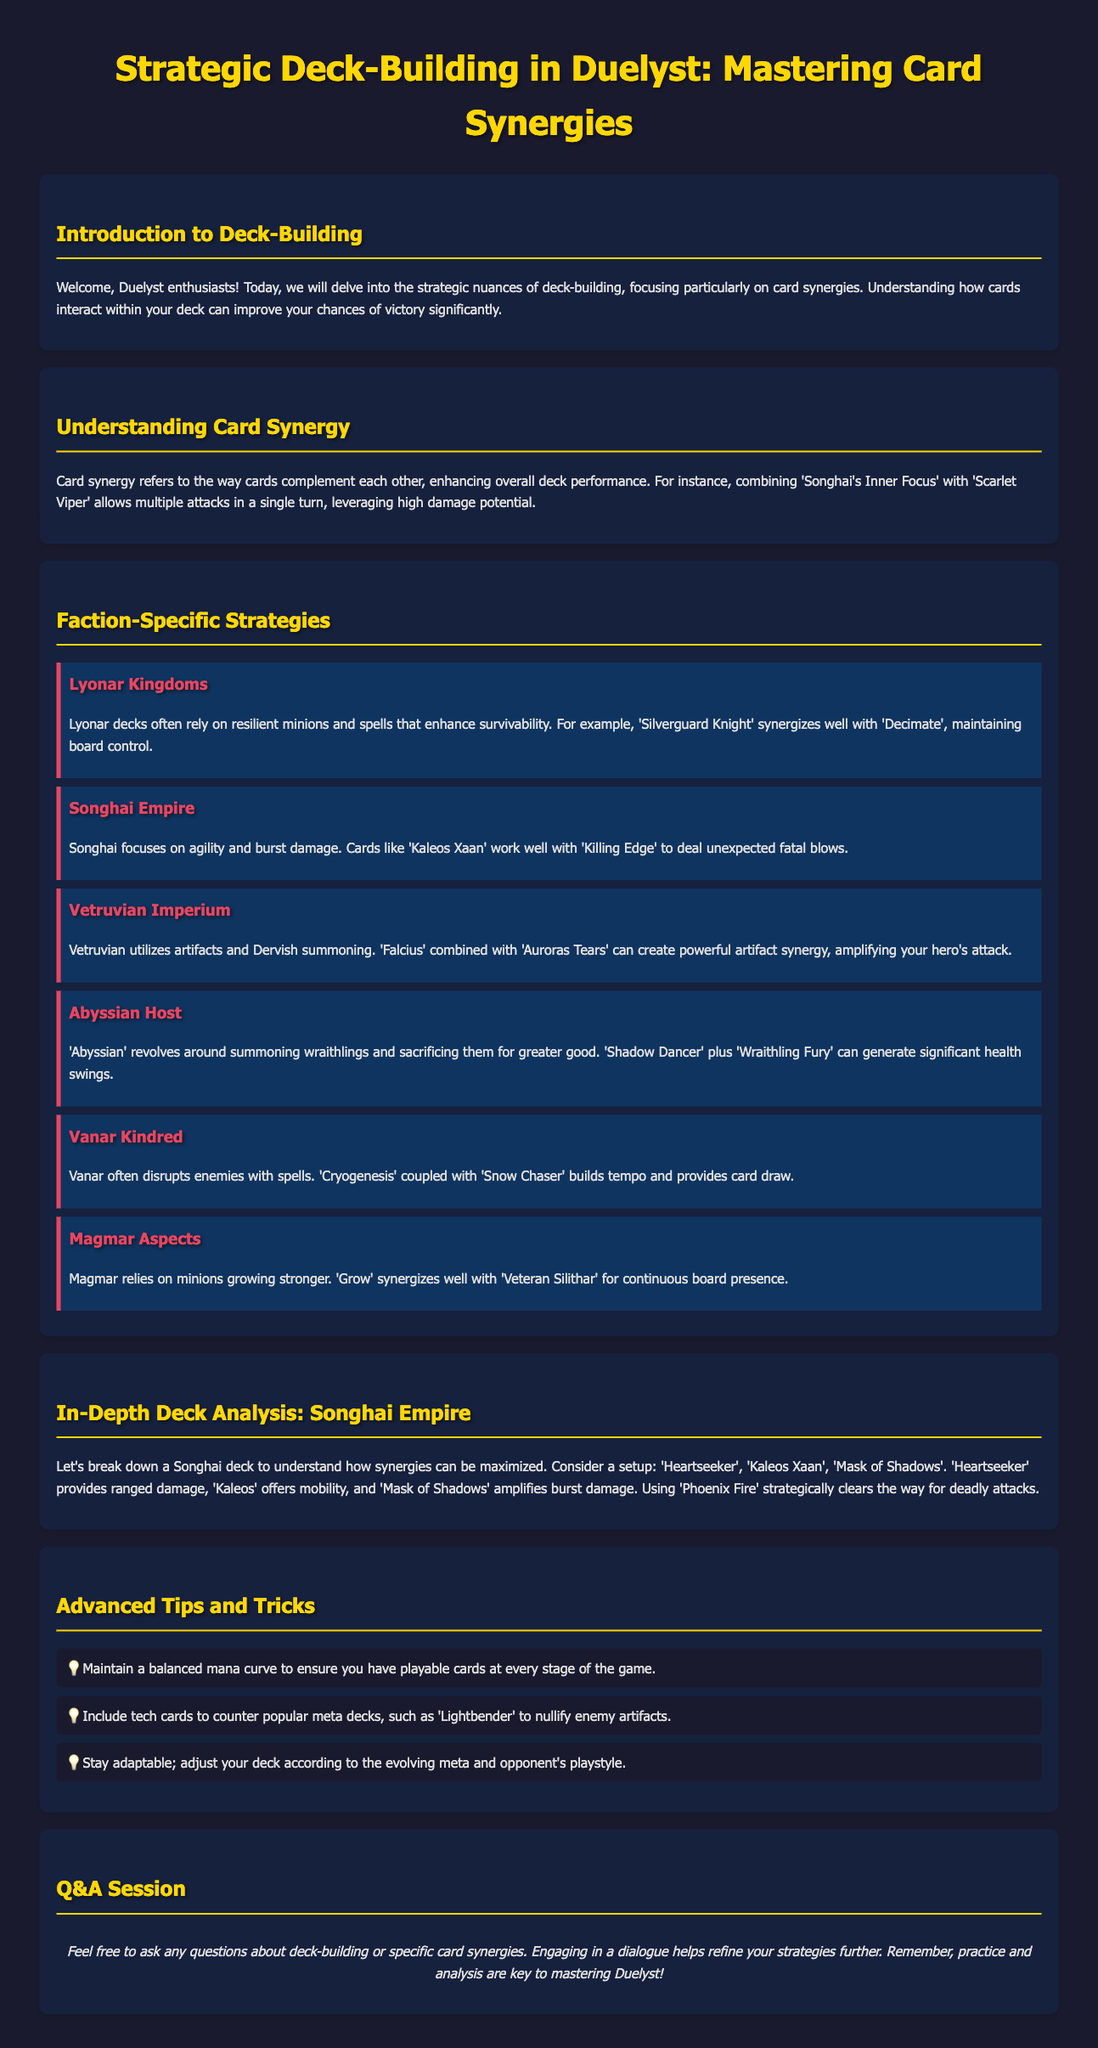What is the title of the workshop? The title of the workshop is presented at the top of the document.
Answer: Strategic Deck-Building in Duelyst: Mastering Card Synergies Which faction is associated with resilient minions? The workshop describes that Lyonar Kingdoms often rely on resilient minions.
Answer: Lyonar Kingdoms What card synergizes well with 'Kaleos Xaan'? The document indicates that 'Killing Edge' works well with 'Kaleos Xaan'.
Answer: Killing Edge How does 'Cryogenesis' benefit Vanar Kindred? The text explains that 'Cryogenesis' coupled with 'Snow Chaser' builds tempo and provides card draw.
Answer: Builds tempo and provides card draw What concept is described as how cards complement each other? The definition in the document describes this concept explicitly.
Answer: Card synergy Which card is mentioned as part of the in-depth analysis for Songhai Empire? The analysis includes specific cards utilized in the Songhai deck example.
Answer: Heartseeker What advanced tip is given regarding mana curve? The document suggests maintaining a balanced mana curve for gameplay strategy.
Answer: Maintain a balanced mana curve Which faction uses Dervish summoning? The workshop notes that Vetruvian Imperium utilizes artifacts and Dervish summoning.
Answer: Vetruvian Imperium What is the main focus of the workshop? The workshop is centered around a specific strategy relevant to the game.
Answer: Deck-building and card synergies 